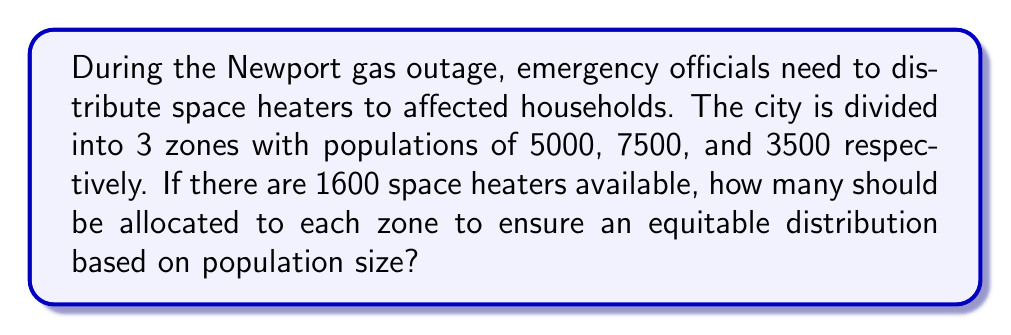Can you answer this question? Let's approach this step-by-step:

1) First, we need to calculate the total population affected:
   $$ \text{Total Population} = 5000 + 7500 + 3500 = 16000 $$

2) Now, we need to determine what fraction of the total population each zone represents:
   Zone 1: $$ \frac{5000}{16000} = \frac{5}{16} = 0.3125 $$
   Zone 2: $$ \frac{7500}{16000} = \frac{15}{32} = 0.46875 $$
   Zone 3: $$ \frac{3500}{16000} = \frac{7}{32} = 0.21875 $$

3) To distribute the heaters equitably, we multiply the total number of heaters by each zone's population fraction:

   Zone 1: $$ 1600 \times \frac{5}{16} = 500 $$
   Zone 2: $$ 1600 \times \frac{15}{32} = 750 $$
   Zone 3: $$ 1600 \times \frac{7}{32} = 350 $$

4) Let's verify that these numbers sum to the total number of heaters:
   $$ 500 + 750 + 350 = 1600 $$

Therefore, the optimal distribution of space heaters is 500 to Zone 1, 750 to Zone 2, and 350 to Zone 3.
Answer: Zone 1: 500, Zone 2: 750, Zone 3: 350 